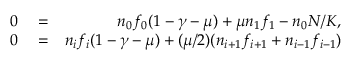Convert formula to latex. <formula><loc_0><loc_0><loc_500><loc_500>\begin{array} { r l r } { 0 } & = } & { n _ { 0 } f _ { 0 } ( 1 - \gamma - \mu ) + \mu n _ { 1 } f _ { 1 } - n _ { 0 } N / K , } \\ { 0 } & = } & { n _ { i } f _ { i } ( 1 - \gamma - \mu ) + ( \mu / 2 ) ( n _ { i + 1 } f _ { i + 1 } + n _ { i - 1 } f _ { i - 1 } ) } \end{array}</formula> 